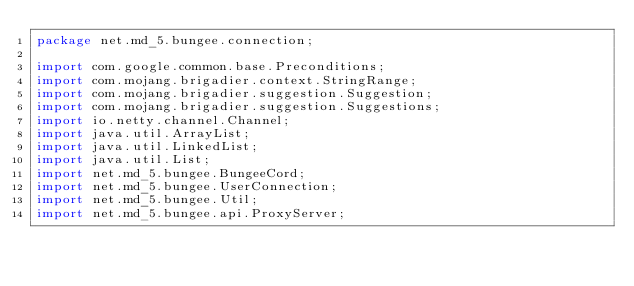<code> <loc_0><loc_0><loc_500><loc_500><_Java_>package net.md_5.bungee.connection;

import com.google.common.base.Preconditions;
import com.mojang.brigadier.context.StringRange;
import com.mojang.brigadier.suggestion.Suggestion;
import com.mojang.brigadier.suggestion.Suggestions;
import io.netty.channel.Channel;
import java.util.ArrayList;
import java.util.LinkedList;
import java.util.List;
import net.md_5.bungee.BungeeCord;
import net.md_5.bungee.UserConnection;
import net.md_5.bungee.Util;
import net.md_5.bungee.api.ProxyServer;</code> 